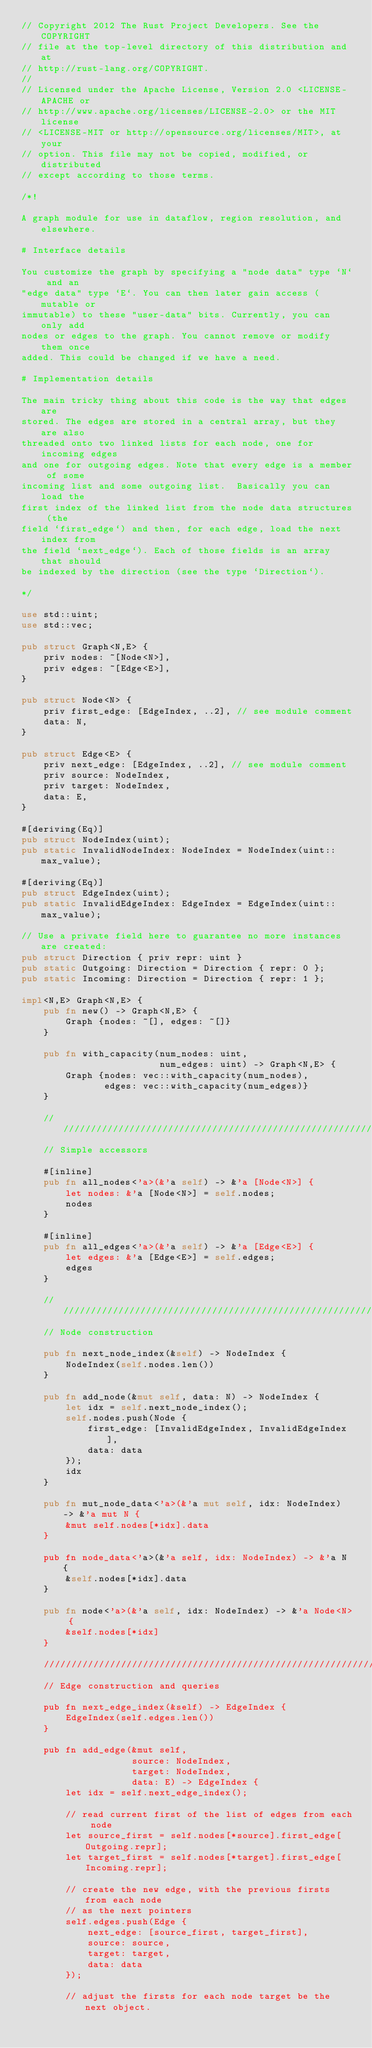Convert code to text. <code><loc_0><loc_0><loc_500><loc_500><_Rust_>// Copyright 2012 The Rust Project Developers. See the COPYRIGHT
// file at the top-level directory of this distribution and at
// http://rust-lang.org/COPYRIGHT.
//
// Licensed under the Apache License, Version 2.0 <LICENSE-APACHE or
// http://www.apache.org/licenses/LICENSE-2.0> or the MIT license
// <LICENSE-MIT or http://opensource.org/licenses/MIT>, at your
// option. This file may not be copied, modified, or distributed
// except according to those terms.

/*!

A graph module for use in dataflow, region resolution, and elsewhere.

# Interface details

You customize the graph by specifying a "node data" type `N` and an
"edge data" type `E`. You can then later gain access (mutable or
immutable) to these "user-data" bits. Currently, you can only add
nodes or edges to the graph. You cannot remove or modify them once
added. This could be changed if we have a need.

# Implementation details

The main tricky thing about this code is the way that edges are
stored. The edges are stored in a central array, but they are also
threaded onto two linked lists for each node, one for incoming edges
and one for outgoing edges. Note that every edge is a member of some
incoming list and some outgoing list.  Basically you can load the
first index of the linked list from the node data structures (the
field `first_edge`) and then, for each edge, load the next index from
the field `next_edge`). Each of those fields is an array that should
be indexed by the direction (see the type `Direction`).

*/

use std::uint;
use std::vec;

pub struct Graph<N,E> {
    priv nodes: ~[Node<N>],
    priv edges: ~[Edge<E>],
}

pub struct Node<N> {
    priv first_edge: [EdgeIndex, ..2], // see module comment
    data: N,
}

pub struct Edge<E> {
    priv next_edge: [EdgeIndex, ..2], // see module comment
    priv source: NodeIndex,
    priv target: NodeIndex,
    data: E,
}

#[deriving(Eq)]
pub struct NodeIndex(uint);
pub static InvalidNodeIndex: NodeIndex = NodeIndex(uint::max_value);

#[deriving(Eq)]
pub struct EdgeIndex(uint);
pub static InvalidEdgeIndex: EdgeIndex = EdgeIndex(uint::max_value);

// Use a private field here to guarantee no more instances are created:
pub struct Direction { priv repr: uint }
pub static Outgoing: Direction = Direction { repr: 0 };
pub static Incoming: Direction = Direction { repr: 1 };

impl<N,E> Graph<N,E> {
    pub fn new() -> Graph<N,E> {
        Graph {nodes: ~[], edges: ~[]}
    }

    pub fn with_capacity(num_nodes: uint,
                         num_edges: uint) -> Graph<N,E> {
        Graph {nodes: vec::with_capacity(num_nodes),
               edges: vec::with_capacity(num_edges)}
    }

    ///////////////////////////////////////////////////////////////////////////
    // Simple accessors

    #[inline]
    pub fn all_nodes<'a>(&'a self) -> &'a [Node<N>] {
        let nodes: &'a [Node<N>] = self.nodes;
        nodes
    }

    #[inline]
    pub fn all_edges<'a>(&'a self) -> &'a [Edge<E>] {
        let edges: &'a [Edge<E>] = self.edges;
        edges
    }

    ///////////////////////////////////////////////////////////////////////////
    // Node construction

    pub fn next_node_index(&self) -> NodeIndex {
        NodeIndex(self.nodes.len())
    }

    pub fn add_node(&mut self, data: N) -> NodeIndex {
        let idx = self.next_node_index();
        self.nodes.push(Node {
            first_edge: [InvalidEdgeIndex, InvalidEdgeIndex],
            data: data
        });
        idx
    }

    pub fn mut_node_data<'a>(&'a mut self, idx: NodeIndex) -> &'a mut N {
        &mut self.nodes[*idx].data
    }

    pub fn node_data<'a>(&'a self, idx: NodeIndex) -> &'a N {
        &self.nodes[*idx].data
    }

    pub fn node<'a>(&'a self, idx: NodeIndex) -> &'a Node<N> {
        &self.nodes[*idx]
    }

    ///////////////////////////////////////////////////////////////////////////
    // Edge construction and queries

    pub fn next_edge_index(&self) -> EdgeIndex {
        EdgeIndex(self.edges.len())
    }

    pub fn add_edge(&mut self,
                    source: NodeIndex,
                    target: NodeIndex,
                    data: E) -> EdgeIndex {
        let idx = self.next_edge_index();

        // read current first of the list of edges from each node
        let source_first = self.nodes[*source].first_edge[Outgoing.repr];
        let target_first = self.nodes[*target].first_edge[Incoming.repr];

        // create the new edge, with the previous firsts from each node
        // as the next pointers
        self.edges.push(Edge {
            next_edge: [source_first, target_first],
            source: source,
            target: target,
            data: data
        });

        // adjust the firsts for each node target be the next object.</code> 